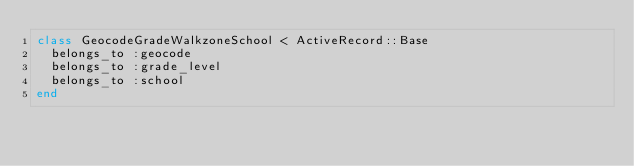Convert code to text. <code><loc_0><loc_0><loc_500><loc_500><_Ruby_>class GeocodeGradeWalkzoneSchool < ActiveRecord::Base
  belongs_to :geocode
  belongs_to :grade_level
  belongs_to :school
end</code> 